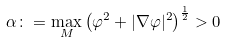<formula> <loc_0><loc_0><loc_500><loc_500>\alpha \colon = \max _ { M } \left ( \varphi ^ { 2 } + | \nabla \varphi | ^ { 2 } \right ) ^ { \frac { 1 } { 2 } } > 0</formula> 